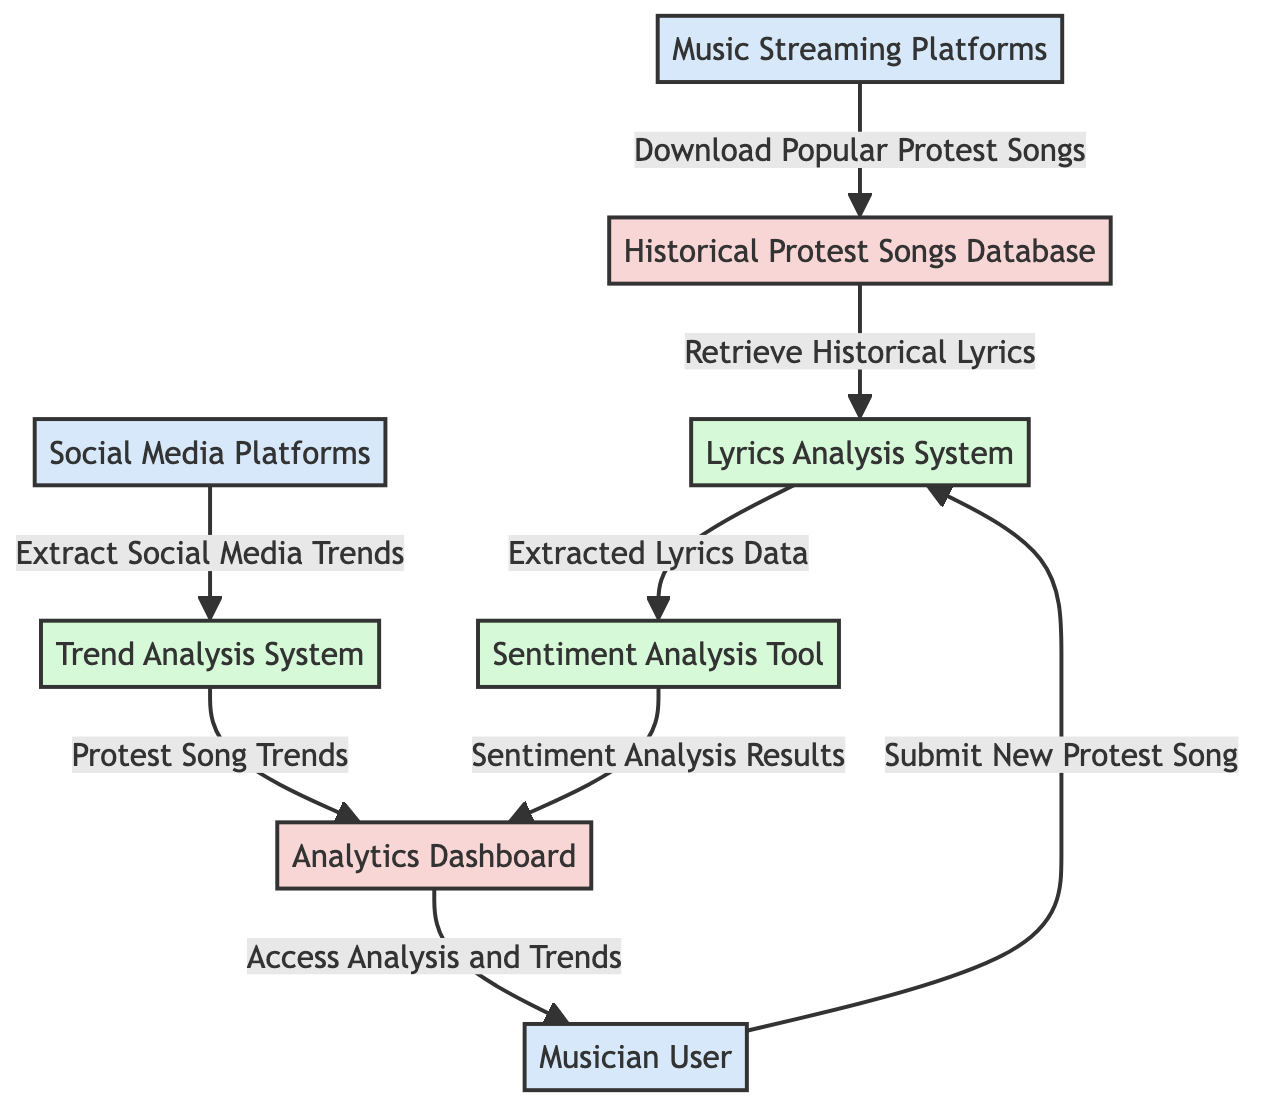What is the first external entity that submits data to the process? The first external entity shown in the diagram is the "Musician User," which submits a new protest song to the "Lyrics Analysis System."
Answer: Musician User How many processes are represented in the diagram? The diagram shows three processes: "Lyrics Analysis System," "Sentiment Analysis Tool," and "Trend Analysis System," making a total of three.
Answer: 3 What data does the "Social Media Platforms" extract? The "Social Media Platforms" extract "Social Media Trends," as indicated by the arrow in the diagram.
Answer: Extract Social Media Trends Which data store receives sentiment analysis results? The "Analytics Dashboard" receives the "Sentiment Analysis Results" from the "Sentiment Analysis Tool."
Answer: Analytics Dashboard What is the flow of data from the "Historical Protest Songs Database" to the "Lyrics Analysis System"? The "Historical Protest Songs Database" supplies "Retrieve Historical Lyrics" to the "Lyrics Analysis System," which indicates the flow of data between them is through historical lyrics retrieval.
Answer: Retrieve Historical Lyrics Which external entity downloads data to the "Historical Protest Songs Database"? The "Music Streaming Platforms" download "Popular Protest Songs" into the "Historical Protest Songs Database."
Answer: Music Streaming Platforms What data is forwarded from the "Trend Analysis System" to the "Analytics Dashboard"? The "Trend Analysis System" forwards "Protest Song Trends" to the "Analytics Dashboard," as depicted by the data flow diagram.
Answer: Protest Song Trends Which process takes input from both the "Lyrics Analysis System" and the "Sentiment Analysis Tool"? The "Analytics Dashboard" receives data from both the "Sentiment Analysis Tool" (sentiment analysis results) and the "Trend Analysis System" (protest song trends).
Answer: Analytics Dashboard What type of entity is the "Analytics Dashboard"? The "Analytics Dashboard" is classified as a data store, as specified in the diagram.
Answer: data store 